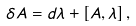Convert formula to latex. <formula><loc_0><loc_0><loc_500><loc_500>\delta A = d \lambda + \left [ A , \lambda \right ] ,</formula> 